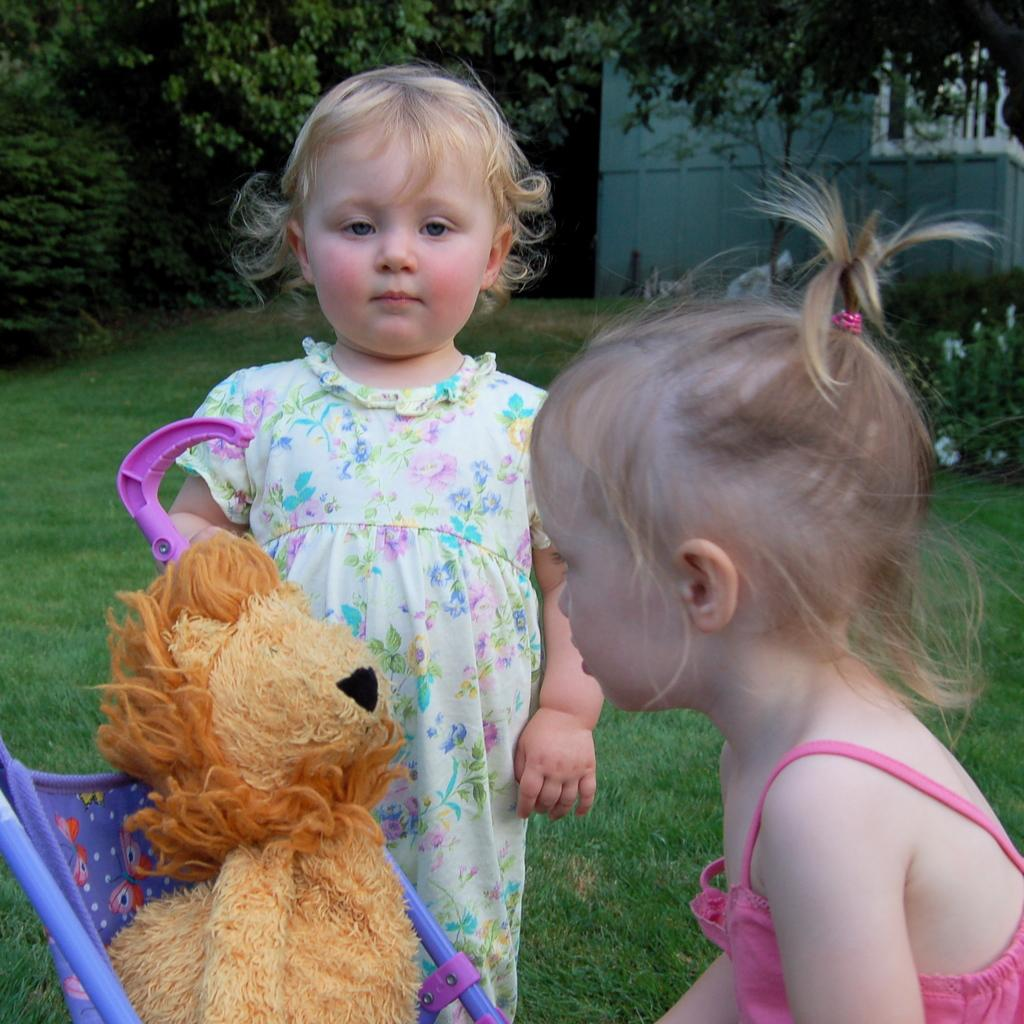How many kids are present in the image? There are two kids in the image. Where are the kids located? The kids are on the grass. What else can be seen in the image besides the kids? There is a toy in the image. What can be seen in the background of the image? There are plants, trees, and a wall in the background of the image. What type of goose is sitting in the middle of the image? There is no goose present in the image; it features two kids on the grass with a toy and a background of plants, trees, and a wall. What type of juice is being served in the image? There is no juice present in the image. 